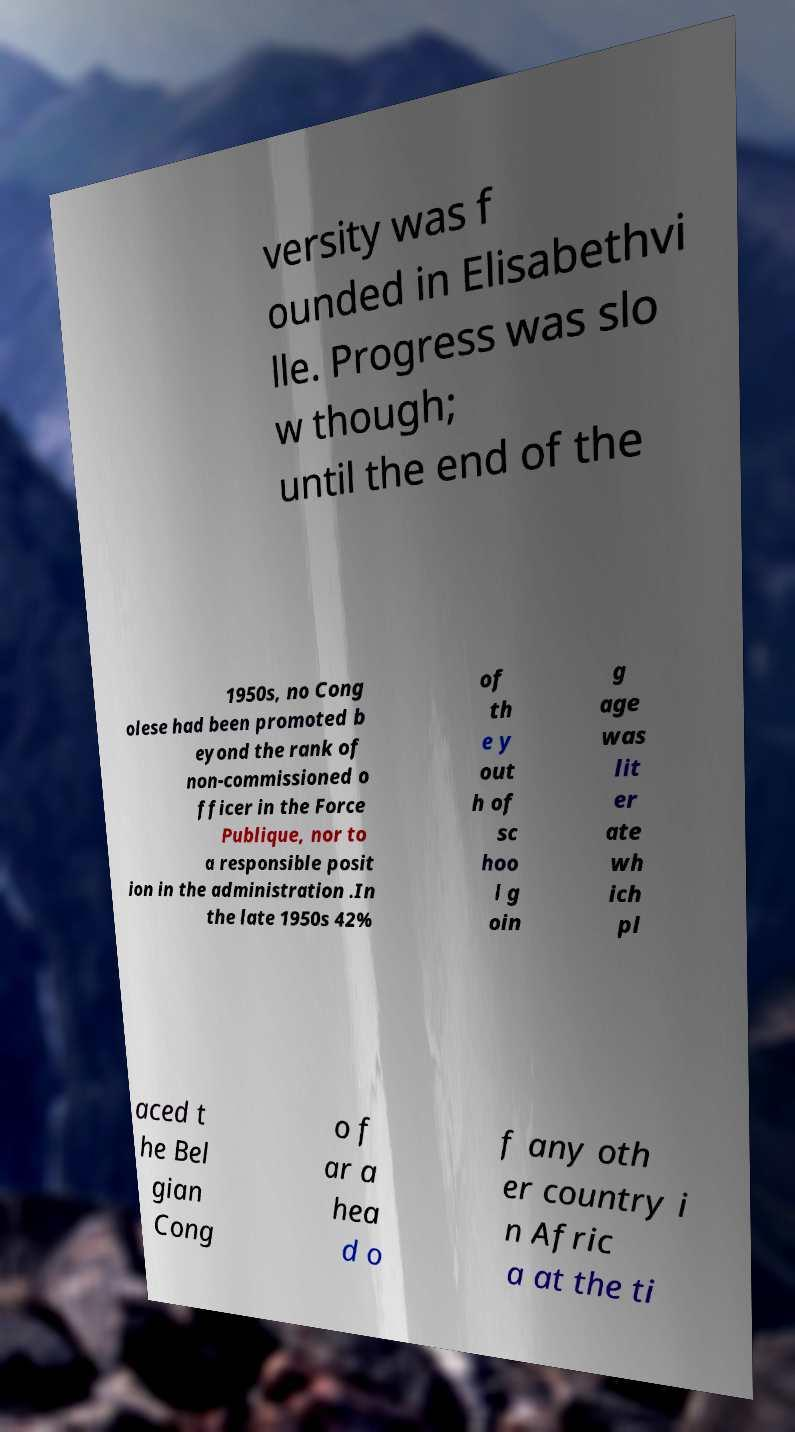Could you assist in decoding the text presented in this image and type it out clearly? versity was f ounded in Elisabethvi lle. Progress was slo w though; until the end of the 1950s, no Cong olese had been promoted b eyond the rank of non-commissioned o fficer in the Force Publique, nor to a responsible posit ion in the administration .In the late 1950s 42% of th e y out h of sc hoo l g oin g age was lit er ate wh ich pl aced t he Bel gian Cong o f ar a hea d o f any oth er country i n Afric a at the ti 